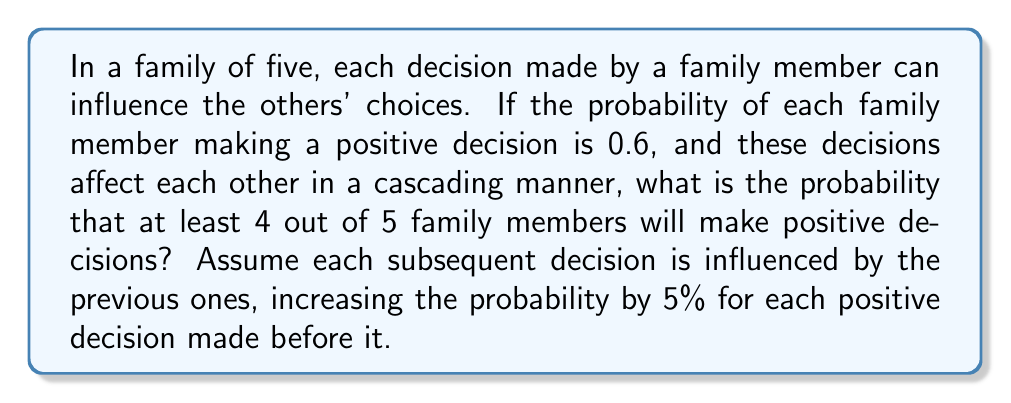Provide a solution to this math problem. Let's approach this step-by-step:

1) First, we need to calculate the probability for each possible scenario where at least 4 out of 5 family members make positive decisions.

2) The scenarios are:
   a) All 5 make positive decisions
   b) Exactly 4 out of 5 make positive decisions

3) For scenario a):
   P(1st) = 0.6
   P(2nd) = 0.6 + 0.05 = 0.65
   P(3rd) = 0.65 + 0.05 = 0.70
   P(4th) = 0.70 + 0.05 = 0.75
   P(5th) = 0.75 + 0.05 = 0.80

   P(all 5) = 0.6 * 0.65 * 0.70 * 0.75 * 0.80 = 0.1638

4) For scenario b), we need to consider all possible combinations where exactly one person makes a negative decision. There are 5 such combinations.

5) Let's calculate one such combination (where the last person makes a negative decision):
   P(4 positive, 1 negative) = 0.6 * 0.65 * 0.70 * 0.75 * (1 - 0.80) = 0.04095

6) Since there are 5 such combinations, we multiply this by 5:
   P(exactly 4 positive) = 5 * 0.04095 = 0.20475

7) The total probability is the sum of the probabilities of both scenarios:
   P(at least 4 positive) = P(all 5 positive) + P(exactly 4 positive)
                          = 0.1638 + 0.20475 = 0.36855

Therefore, the probability that at least 4 out of 5 family members will make positive decisions is approximately 0.36855 or 36.855%.
Answer: 0.36855 